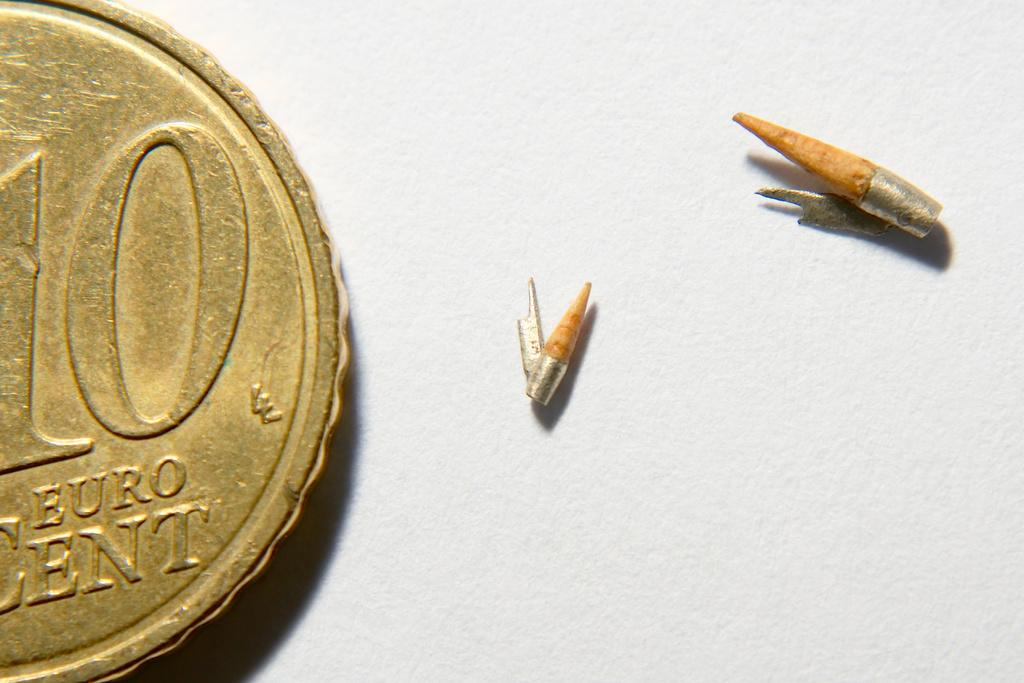Provide a one-sentence caption for the provided image. Two small, pointy objects sit near a 10 cent euro. 